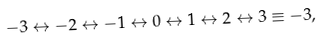Convert formula to latex. <formula><loc_0><loc_0><loc_500><loc_500>- 3 \leftrightarrow - 2 \leftrightarrow - 1 \leftrightarrow 0 \leftrightarrow 1 \leftrightarrow 2 \leftrightarrow 3 \equiv - 3 ,</formula> 